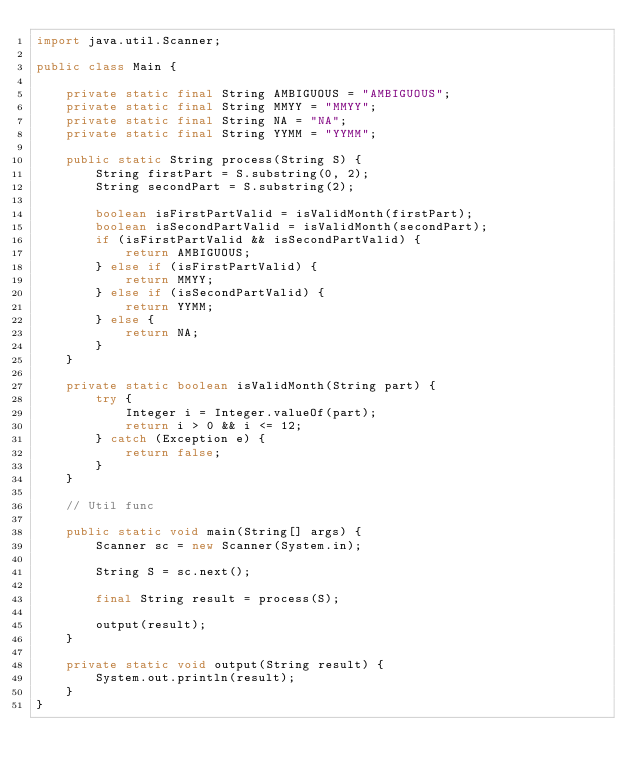<code> <loc_0><loc_0><loc_500><loc_500><_Java_>import java.util.Scanner;

public class Main {

    private static final String AMBIGUOUS = "AMBIGUOUS";
    private static final String MMYY = "MMYY";
    private static final String NA = "NA";
    private static final String YYMM = "YYMM";

    public static String process(String S) {
        String firstPart = S.substring(0, 2);
        String secondPart = S.substring(2);

        boolean isFirstPartValid = isValidMonth(firstPart);
        boolean isSecondPartValid = isValidMonth(secondPart);
        if (isFirstPartValid && isSecondPartValid) {
            return AMBIGUOUS;
        } else if (isFirstPartValid) {
            return MMYY;
        } else if (isSecondPartValid) {
            return YYMM;
        } else {
            return NA;
        }
    }

    private static boolean isValidMonth(String part) {
        try {
            Integer i = Integer.valueOf(part);
            return i > 0 && i <= 12;
        } catch (Exception e) {
            return false;
        }
    }

    // Util func

    public static void main(String[] args) {
        Scanner sc = new Scanner(System.in);

        String S = sc.next();

        final String result = process(S);

        output(result);
    }

    private static void output(String result) {
        System.out.println(result);
    }
}
</code> 